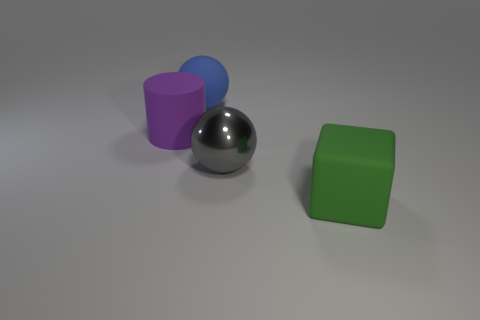How many things are either matte blocks in front of the cylinder or large blue spheres?
Your answer should be compact. 2. What number of objects are on the right side of the object that is to the left of the big blue rubber sphere?
Keep it short and to the point. 3. Are there more gray balls to the right of the large matte block than large rubber cylinders?
Give a very brief answer. No. The big thing that is to the left of the green rubber block and in front of the large purple cylinder has what shape?
Give a very brief answer. Sphere. There is a matte thing that is in front of the big sphere in front of the large purple matte cylinder; is there a large purple cylinder that is to the right of it?
Offer a terse response. No. How many objects are either large blocks to the right of the big rubber cylinder or large objects that are right of the purple cylinder?
Provide a succinct answer. 3. Is the object behind the purple thing made of the same material as the gray thing?
Keep it short and to the point. No. What material is the big object that is both right of the large rubber sphere and to the left of the big green block?
Provide a short and direct response. Metal. What is the color of the big sphere on the right side of the large thing behind the big cylinder?
Offer a very short reply. Gray. There is a large gray object that is the same shape as the big blue matte object; what material is it?
Provide a succinct answer. Metal. 